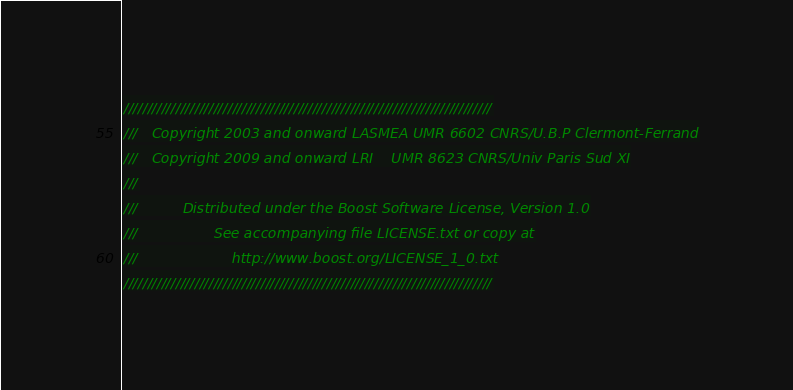<code> <loc_0><loc_0><loc_500><loc_500><_C++_>//////////////////////////////////////////////////////////////////////////////
///   Copyright 2003 and onward LASMEA UMR 6602 CNRS/U.B.P Clermont-Ferrand
///   Copyright 2009 and onward LRI    UMR 8623 CNRS/Univ Paris Sud XI
///
///          Distributed under the Boost Software License, Version 1.0
///                 See accompanying file LICENSE.txt or copy at
///                     http://www.boost.org/LICENSE_1_0.txt
//////////////////////////////////////////////////////////////////////////////</code> 